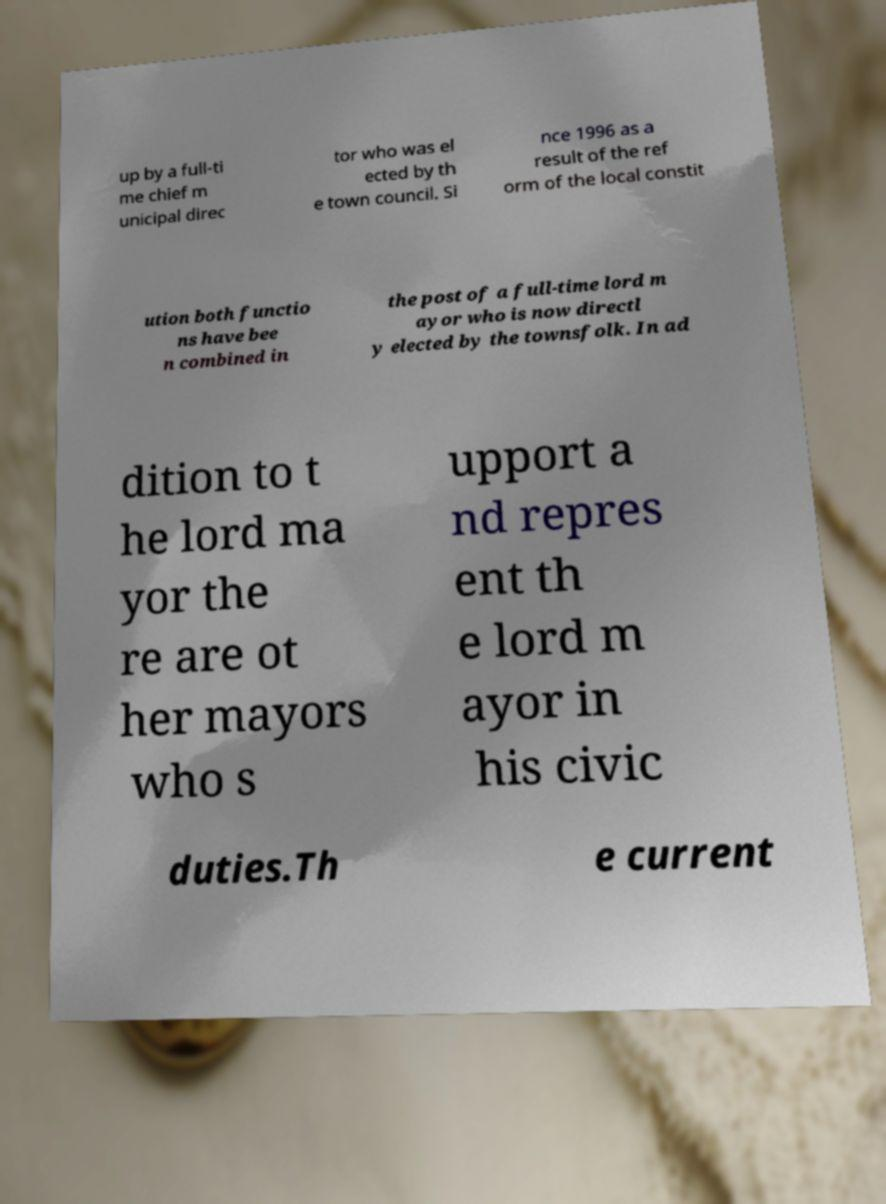What messages or text are displayed in this image? I need them in a readable, typed format. up by a full-ti me chief m unicipal direc tor who was el ected by th e town council. Si nce 1996 as a result of the ref orm of the local constit ution both functio ns have bee n combined in the post of a full-time lord m ayor who is now directl y elected by the townsfolk. In ad dition to t he lord ma yor the re are ot her mayors who s upport a nd repres ent th e lord m ayor in his civic duties.Th e current 